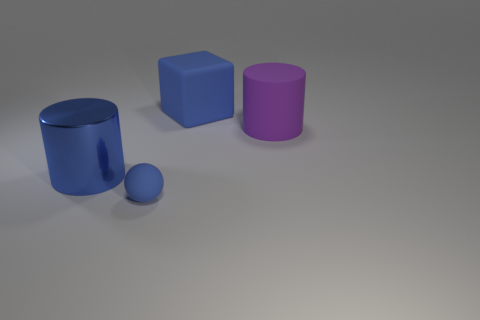Add 3 cyan metal things. How many objects exist? 7 Subtract all cubes. How many objects are left? 3 Subtract all small rubber things. Subtract all large red balls. How many objects are left? 3 Add 4 matte balls. How many matte balls are left? 5 Add 2 small spheres. How many small spheres exist? 3 Subtract 0 yellow blocks. How many objects are left? 4 